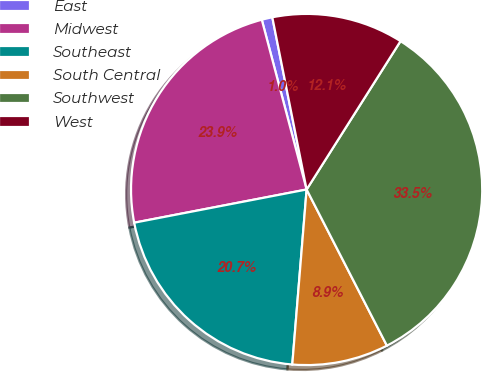Convert chart. <chart><loc_0><loc_0><loc_500><loc_500><pie_chart><fcel>East<fcel>Midwest<fcel>Southeast<fcel>South Central<fcel>Southwest<fcel>West<nl><fcel>0.98%<fcel>23.92%<fcel>20.67%<fcel>8.86%<fcel>33.46%<fcel>12.11%<nl></chart> 